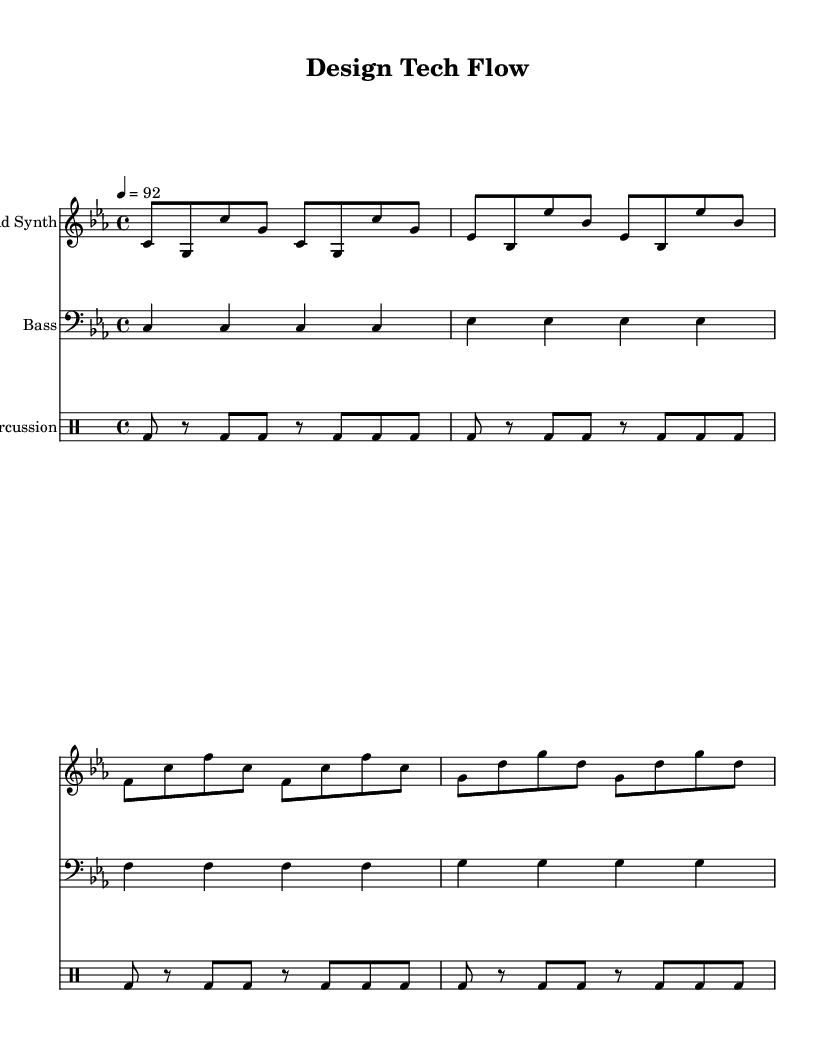What is the key signature of this music? The key signature is shown at the beginning of the staff and indicates the pitches to be altered. In this case, the key signature that involves the three flats is C minor.
Answer: C minor What is the time signature? The time signature is visible at the beginning of the staff, indicating how many beats are in each measure. Here, it shows 4 beats per measure, thus the time signature is 4/4.
Answer: 4/4 What is the tempo marking? The tempo marking is indicated at the start of the score with a number and note type which tells the players how fast to play. Here, it states a tempo of 92 beats per minute.
Answer: 92 How many measures are in the lead synth part? By counting the individual groups of notes marked by bar lines, we find that there are 8 measures in the lead synth part.
Answer: 8 Which instrument is playing the bass line? The staff labelled clearly shows that the bass line is performed by the instrument specified as "Bass."
Answer: Bass What lyrical theme is presented in the text? The lyrics convey a theme of blending art and technology in modern design, discussing the aesthetic aspects of industrial design. Thus the theme reflects on the intersection of creativity and functionality.
Answer: Intersection of art and technology What rhythm pattern is used for percussion? The rhythm pattern in the percussion section consists of bass drum hits represented by 'bd' in a repeated sequence, creating a consistent and driving beat, showing a basic repetitive 8th note pattern.
Answer: Repetitive 8th note pattern 